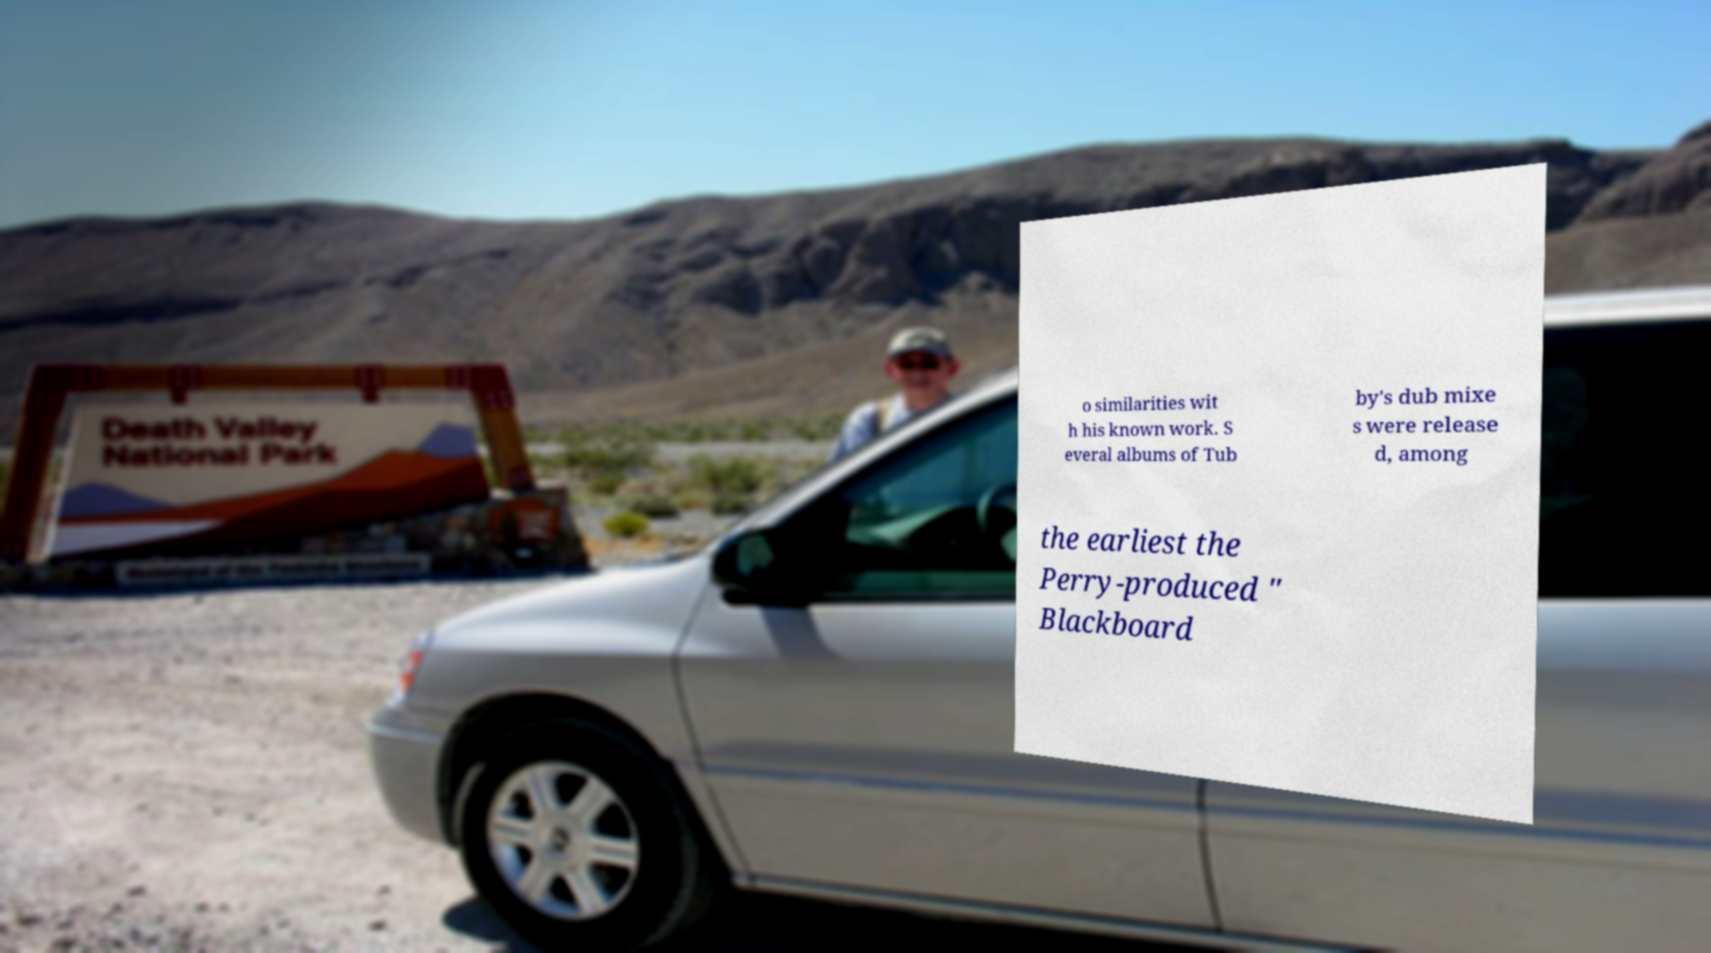There's text embedded in this image that I need extracted. Can you transcribe it verbatim? o similarities wit h his known work. S everal albums of Tub by's dub mixe s were release d, among the earliest the Perry-produced " Blackboard 